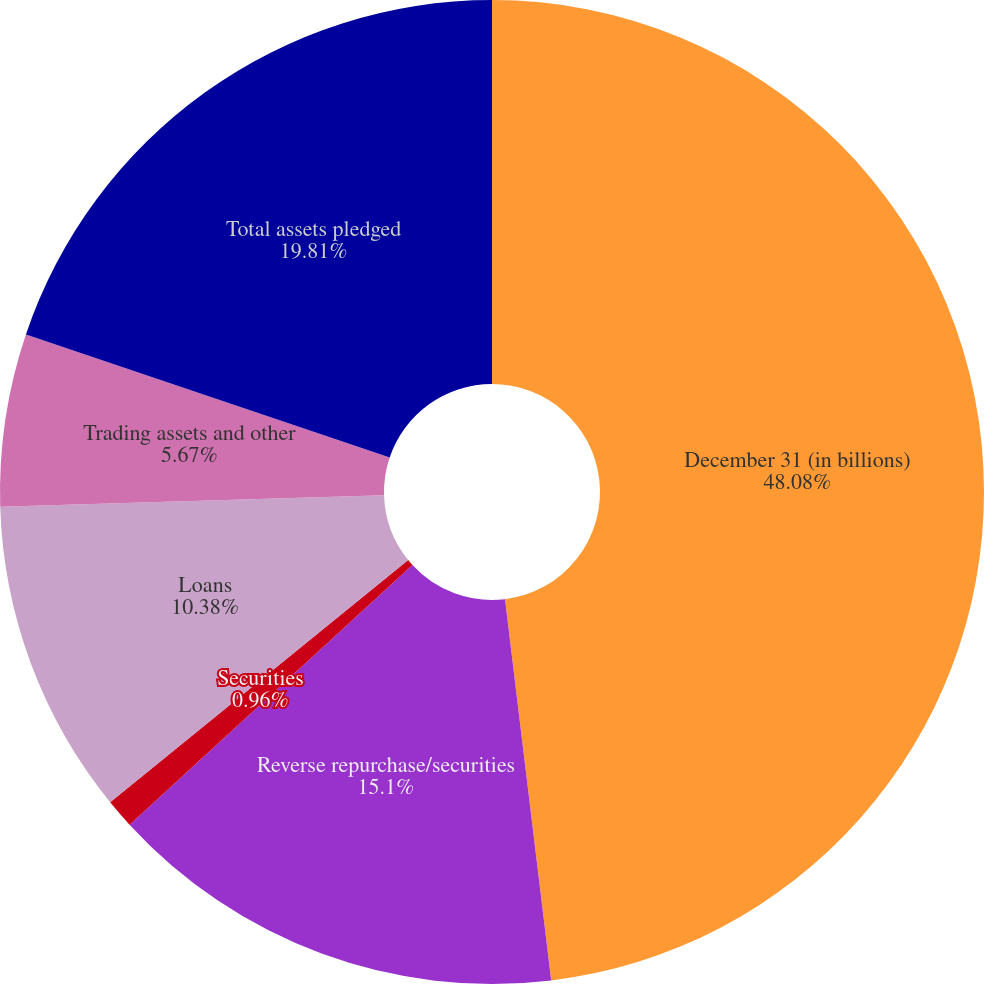<chart> <loc_0><loc_0><loc_500><loc_500><pie_chart><fcel>December 31 (in billions)<fcel>Reverse repurchase/securities<fcel>Securities<fcel>Loans<fcel>Trading assets and other<fcel>Total assets pledged<nl><fcel>48.08%<fcel>15.1%<fcel>0.96%<fcel>10.38%<fcel>5.67%<fcel>19.81%<nl></chart> 